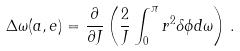<formula> <loc_0><loc_0><loc_500><loc_500>\Delta \omega ( a , e ) = \frac { \partial } { \partial J } \left ( \frac { 2 } { J } \int _ { 0 } ^ { \pi } r ^ { 2 } \delta \phi d \omega \right ) \, .</formula> 